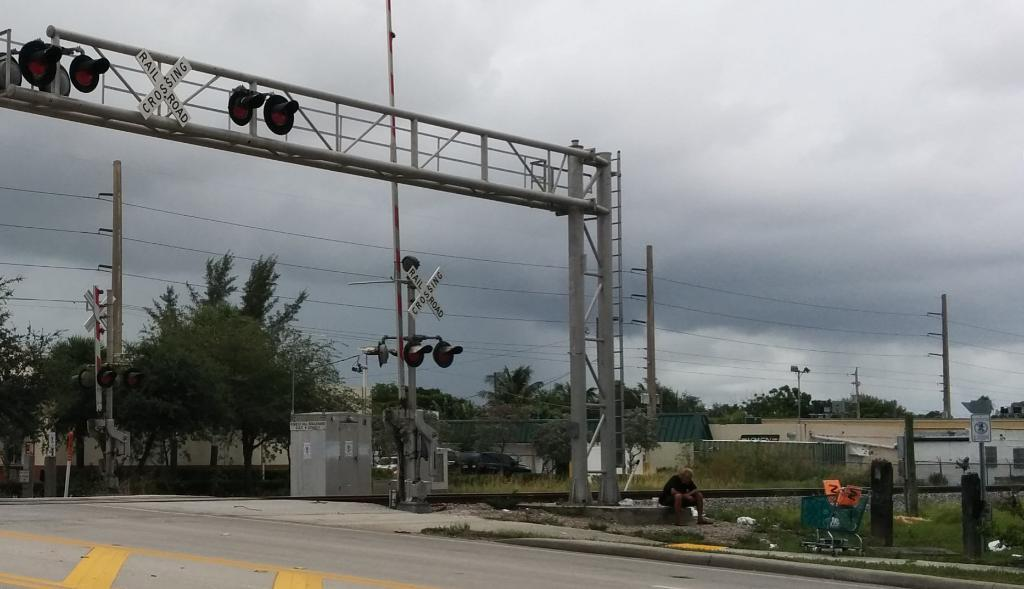<image>
Provide a brief description of the given image. Two strips of wood in the shape of an x say railroad crossing. 